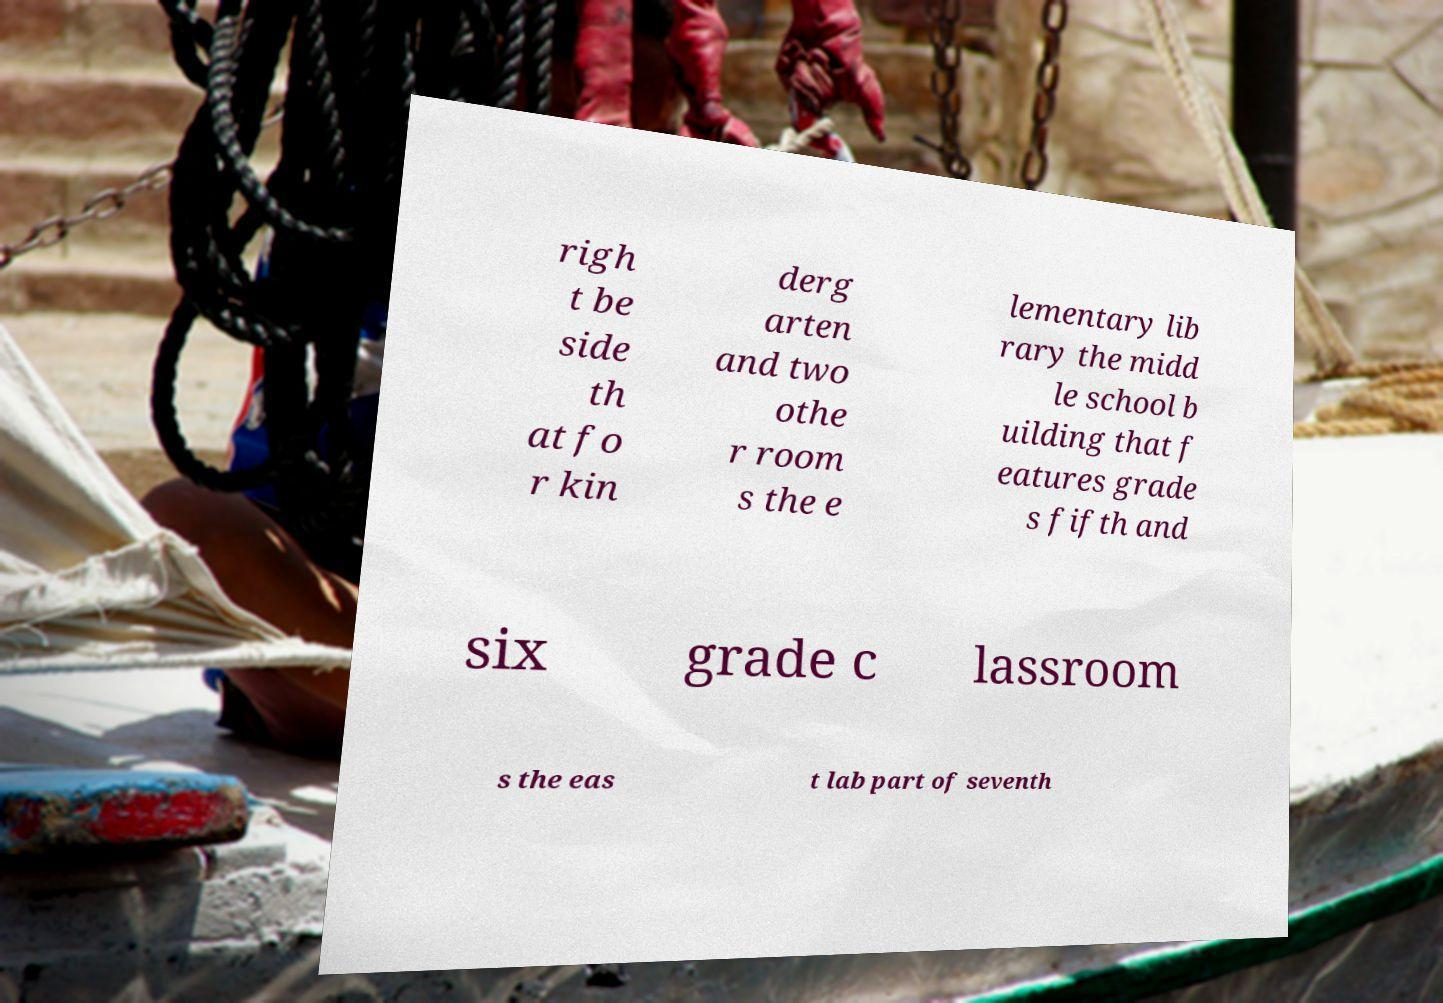Could you extract and type out the text from this image? righ t be side th at fo r kin derg arten and two othe r room s the e lementary lib rary the midd le school b uilding that f eatures grade s fifth and six grade c lassroom s the eas t lab part of seventh 